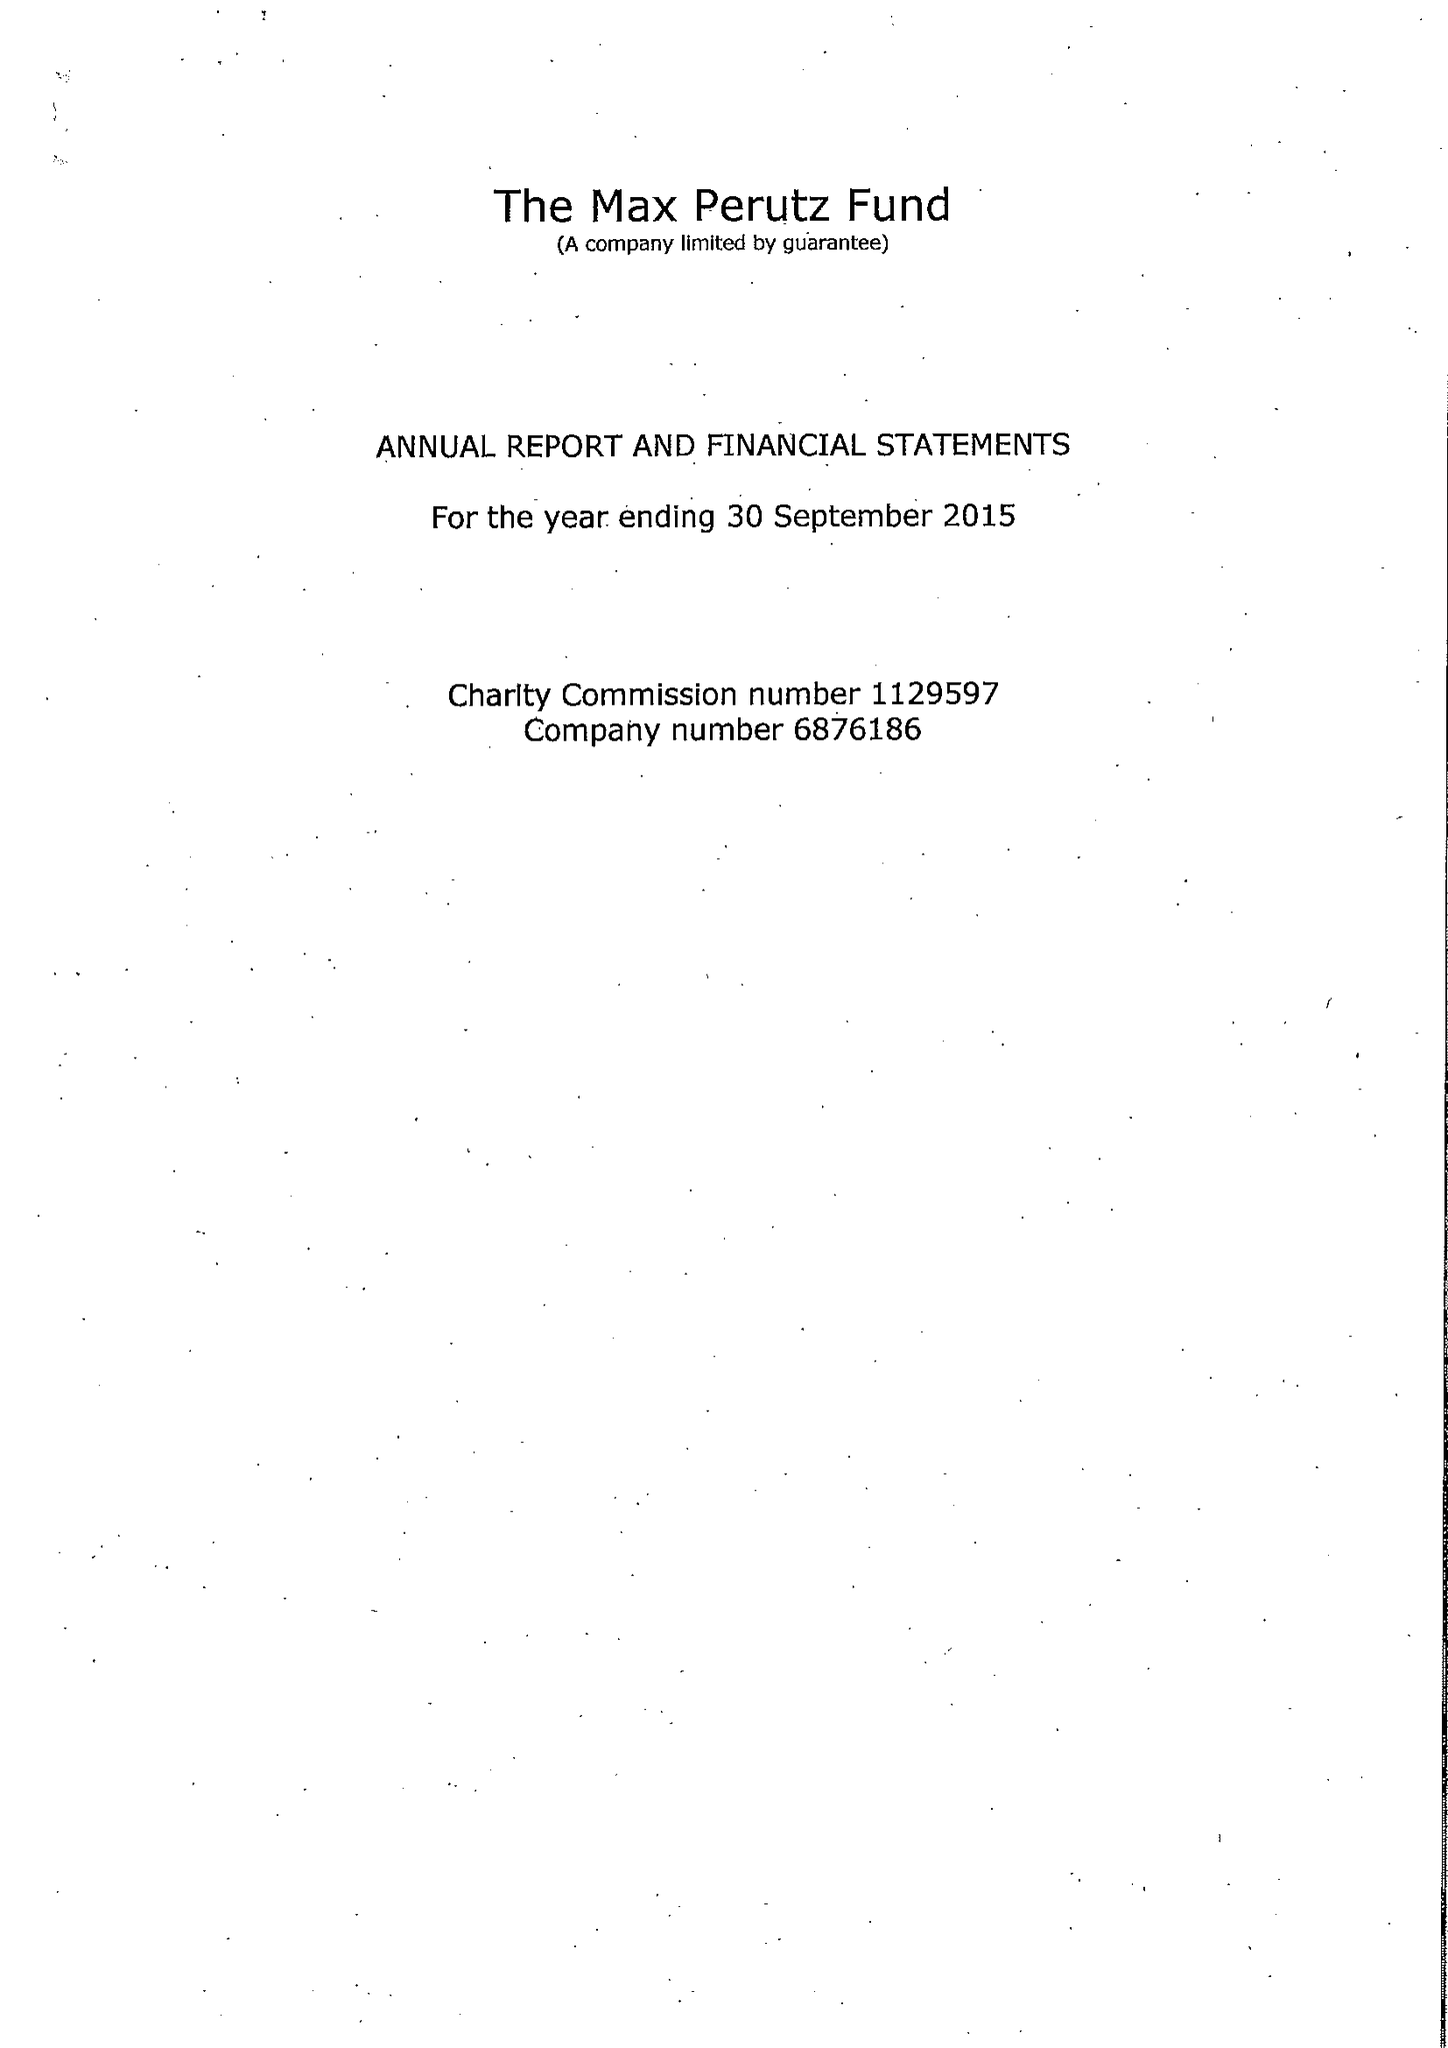What is the value for the charity_number?
Answer the question using a single word or phrase. 1129597 